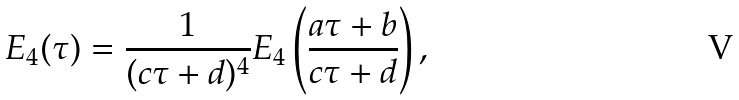Convert formula to latex. <formula><loc_0><loc_0><loc_500><loc_500>E _ { 4 } ( \tau ) = \frac { 1 } { ( c \tau + d ) ^ { 4 } } E _ { 4 } \left ( \frac { a \tau + b } { c \tau + d } \right ) ,</formula> 